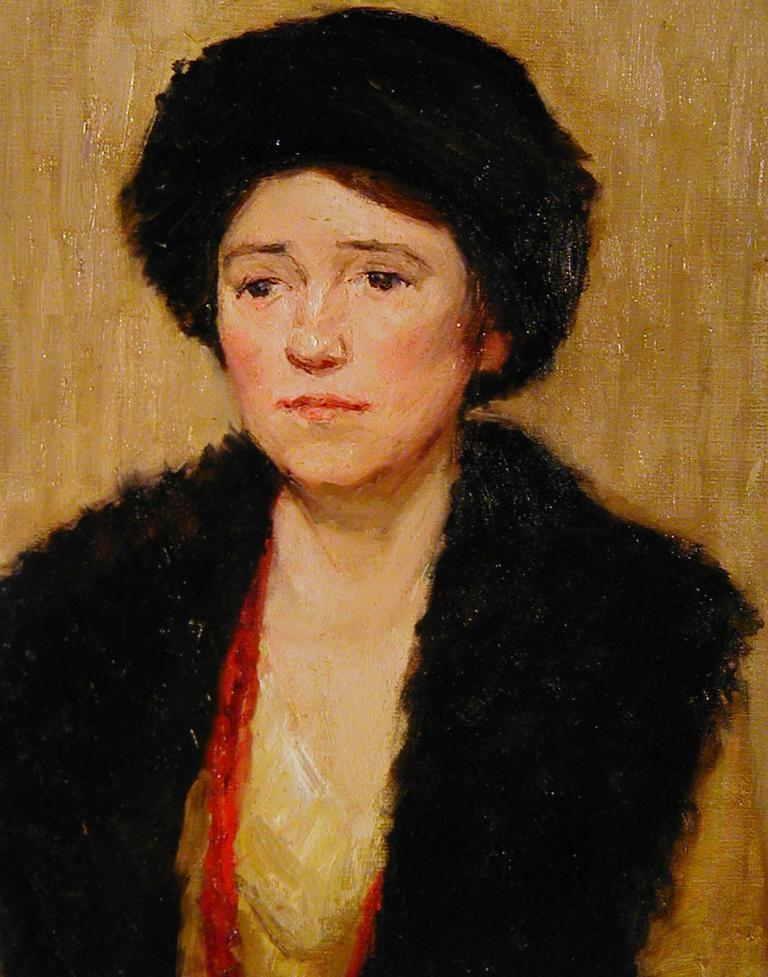What is the main subject of the image? There is a person in the image. What is the person doing in the image? The person is painting. How does the person increase the size of the bread in the image? There is no bread present in the image, and the person is not performing any action related to increasing the size of bread. 